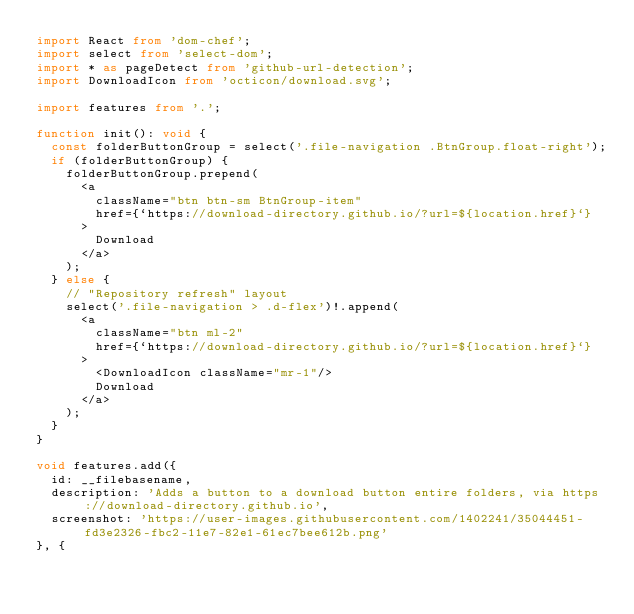<code> <loc_0><loc_0><loc_500><loc_500><_TypeScript_>import React from 'dom-chef';
import select from 'select-dom';
import * as pageDetect from 'github-url-detection';
import DownloadIcon from 'octicon/download.svg';

import features from '.';

function init(): void {
	const folderButtonGroup = select('.file-navigation .BtnGroup.float-right');
	if (folderButtonGroup) {
		folderButtonGroup.prepend(
			<a
				className="btn btn-sm BtnGroup-item"
				href={`https://download-directory.github.io/?url=${location.href}`}
			>
				Download
			</a>
		);
	} else {
		// "Repository refresh" layout
		select('.file-navigation > .d-flex')!.append(
			<a
				className="btn ml-2"
				href={`https://download-directory.github.io/?url=${location.href}`}
			>
				<DownloadIcon className="mr-1"/>
				Download
			</a>
		);
	}
}

void features.add({
	id: __filebasename,
	description: 'Adds a button to a download button entire folders, via https://download-directory.github.io',
	screenshot: 'https://user-images.githubusercontent.com/1402241/35044451-fd3e2326-fbc2-11e7-82e1-61ec7bee612b.png'
}, {</code> 